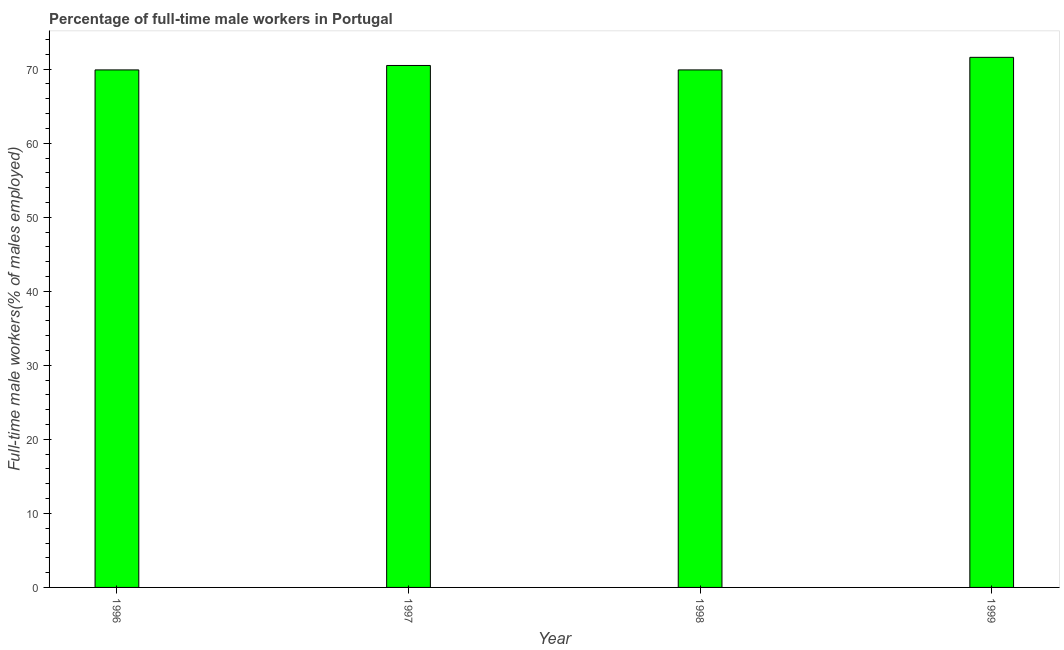Does the graph contain grids?
Your response must be concise. No. What is the title of the graph?
Provide a succinct answer. Percentage of full-time male workers in Portugal. What is the label or title of the Y-axis?
Give a very brief answer. Full-time male workers(% of males employed). What is the percentage of full-time male workers in 1997?
Offer a very short reply. 70.5. Across all years, what is the maximum percentage of full-time male workers?
Make the answer very short. 71.6. Across all years, what is the minimum percentage of full-time male workers?
Your answer should be very brief. 69.9. In which year was the percentage of full-time male workers maximum?
Keep it short and to the point. 1999. What is the sum of the percentage of full-time male workers?
Give a very brief answer. 281.9. What is the difference between the percentage of full-time male workers in 1996 and 1997?
Give a very brief answer. -0.6. What is the average percentage of full-time male workers per year?
Offer a terse response. 70.47. What is the median percentage of full-time male workers?
Your response must be concise. 70.2. Do a majority of the years between 1998 and 1997 (inclusive) have percentage of full-time male workers greater than 30 %?
Offer a very short reply. No. What is the difference between the highest and the second highest percentage of full-time male workers?
Ensure brevity in your answer.  1.1. Is the sum of the percentage of full-time male workers in 1997 and 1998 greater than the maximum percentage of full-time male workers across all years?
Provide a short and direct response. Yes. What is the difference between the highest and the lowest percentage of full-time male workers?
Keep it short and to the point. 1.7. Are all the bars in the graph horizontal?
Your answer should be compact. No. What is the difference between two consecutive major ticks on the Y-axis?
Provide a short and direct response. 10. What is the Full-time male workers(% of males employed) of 1996?
Keep it short and to the point. 69.9. What is the Full-time male workers(% of males employed) in 1997?
Ensure brevity in your answer.  70.5. What is the Full-time male workers(% of males employed) in 1998?
Your response must be concise. 69.9. What is the Full-time male workers(% of males employed) of 1999?
Give a very brief answer. 71.6. What is the difference between the Full-time male workers(% of males employed) in 1996 and 1999?
Ensure brevity in your answer.  -1.7. What is the difference between the Full-time male workers(% of males employed) in 1998 and 1999?
Make the answer very short. -1.7. What is the ratio of the Full-time male workers(% of males employed) in 1996 to that in 1997?
Offer a very short reply. 0.99. What is the ratio of the Full-time male workers(% of males employed) in 1996 to that in 1999?
Give a very brief answer. 0.98. What is the ratio of the Full-time male workers(% of males employed) in 1997 to that in 1998?
Your answer should be compact. 1.01. What is the ratio of the Full-time male workers(% of males employed) in 1997 to that in 1999?
Keep it short and to the point. 0.98. 